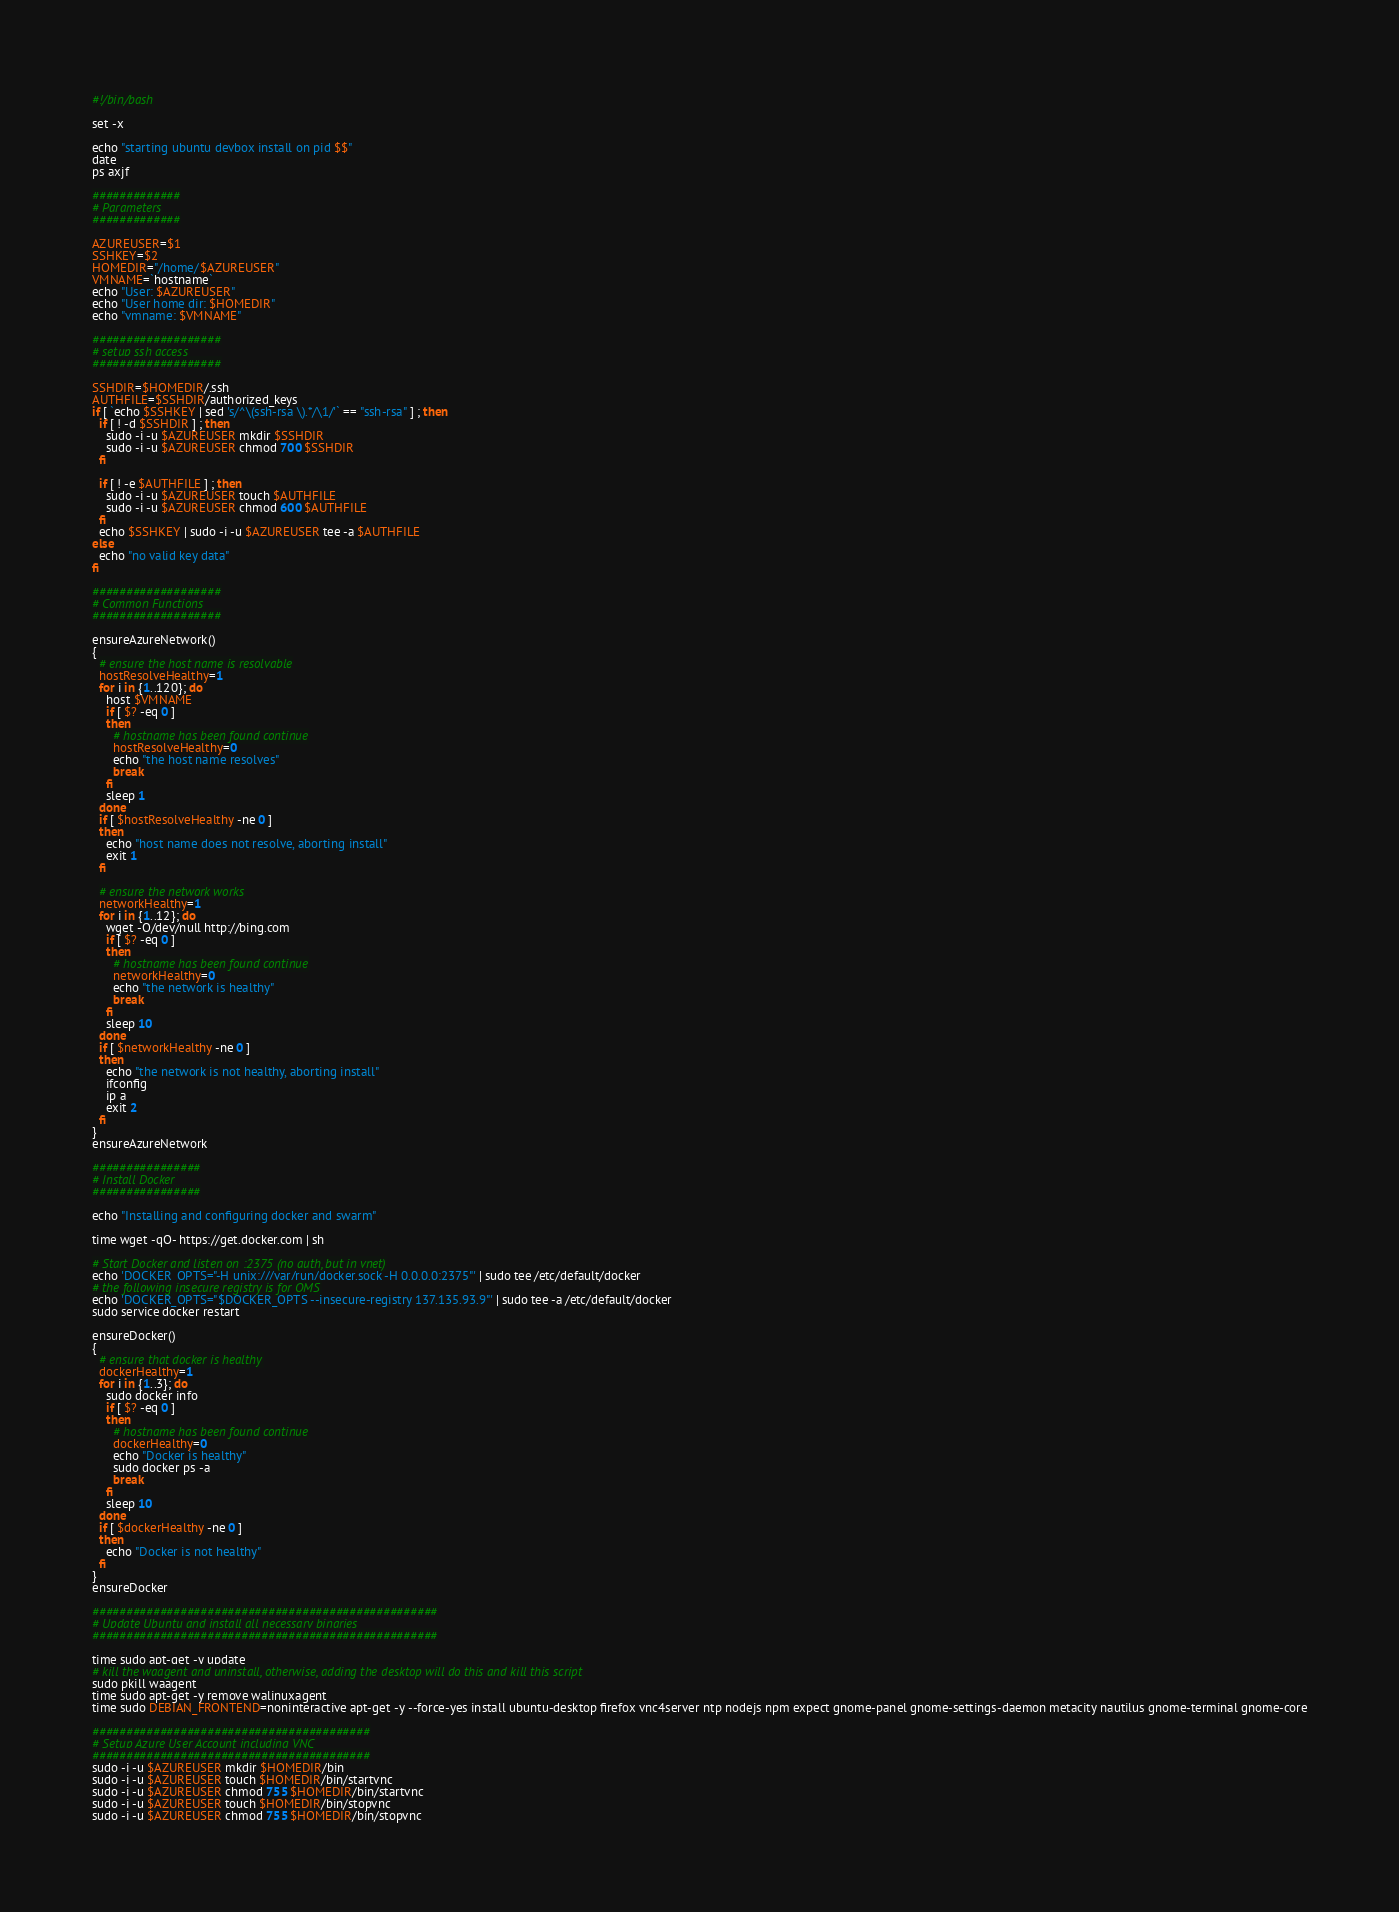Convert code to text. <code><loc_0><loc_0><loc_500><loc_500><_Bash_>#!/bin/bash

set -x

echo "starting ubuntu devbox install on pid $$"
date
ps axjf

#############
# Parameters
#############

AZUREUSER=$1
SSHKEY=$2
HOMEDIR="/home/$AZUREUSER"
VMNAME=`hostname`
echo "User: $AZUREUSER"
echo "User home dir: $HOMEDIR"
echo "vmname: $VMNAME"

###################
# setup ssh access
###################

SSHDIR=$HOMEDIR/.ssh
AUTHFILE=$SSHDIR/authorized_keys
if [ `echo $SSHKEY | sed 's/^\(ssh-rsa \).*/\1/'` == "ssh-rsa" ] ; then
  if [ ! -d $SSHDIR ] ; then
    sudo -i -u $AZUREUSER mkdir $SSHDIR
    sudo -i -u $AZUREUSER chmod 700 $SSHDIR
  fi

  if [ ! -e $AUTHFILE ] ; then
    sudo -i -u $AZUREUSER touch $AUTHFILE
    sudo -i -u $AZUREUSER chmod 600 $AUTHFILE
  fi
  echo $SSHKEY | sudo -i -u $AZUREUSER tee -a $AUTHFILE
else
  echo "no valid key data"
fi

###################
# Common Functions
###################

ensureAzureNetwork()
{
  # ensure the host name is resolvable
  hostResolveHealthy=1
  for i in {1..120}; do
    host $VMNAME
    if [ $? -eq 0 ]
    then
      # hostname has been found continue
      hostResolveHealthy=0
      echo "the host name resolves"
      break
    fi
    sleep 1
  done
  if [ $hostResolveHealthy -ne 0 ]
  then
    echo "host name does not resolve, aborting install"
    exit 1
  fi

  # ensure the network works
  networkHealthy=1
  for i in {1..12}; do
    wget -O/dev/null http://bing.com
    if [ $? -eq 0 ]
    then
      # hostname has been found continue
      networkHealthy=0
      echo "the network is healthy"
      break
    fi
    sleep 10
  done
  if [ $networkHealthy -ne 0 ]
  then
    echo "the network is not healthy, aborting install"
    ifconfig
    ip a
    exit 2
  fi
}
ensureAzureNetwork

################
# Install Docker
################

echo "Installing and configuring docker and swarm"

time wget -qO- https://get.docker.com | sh

# Start Docker and listen on :2375 (no auth, but in vnet)
echo 'DOCKER_OPTS="-H unix:///var/run/docker.sock -H 0.0.0.0:2375"' | sudo tee /etc/default/docker
# the following insecure registry is for OMS
echo 'DOCKER_OPTS="$DOCKER_OPTS --insecure-registry 137.135.93.9"' | sudo tee -a /etc/default/docker
sudo service docker restart

ensureDocker()
{
  # ensure that docker is healthy
  dockerHealthy=1
  for i in {1..3}; do
    sudo docker info
    if [ $? -eq 0 ]
    then
      # hostname has been found continue
      dockerHealthy=0
      echo "Docker is healthy"
      sudo docker ps -a
      break
    fi
    sleep 10
  done
  if [ $dockerHealthy -ne 0 ]
  then
    echo "Docker is not healthy"
  fi
}
ensureDocker

###################################################
# Update Ubuntu and install all necessary binaries
###################################################

time sudo apt-get -y update
# kill the waagent and uninstall, otherwise, adding the desktop will do this and kill this script
sudo pkill waagent
time sudo apt-get -y remove walinuxagent
time sudo DEBIAN_FRONTEND=noninteractive apt-get -y --force-yes install ubuntu-desktop firefox vnc4server ntp nodejs npm expect gnome-panel gnome-settings-daemon metacity nautilus gnome-terminal gnome-core

#########################################
# Setup Azure User Account including VNC
#########################################
sudo -i -u $AZUREUSER mkdir $HOMEDIR/bin
sudo -i -u $AZUREUSER touch $HOMEDIR/bin/startvnc
sudo -i -u $AZUREUSER chmod 755 $HOMEDIR/bin/startvnc
sudo -i -u $AZUREUSER touch $HOMEDIR/bin/stopvnc
sudo -i -u $AZUREUSER chmod 755 $HOMEDIR/bin/stopvnc</code> 